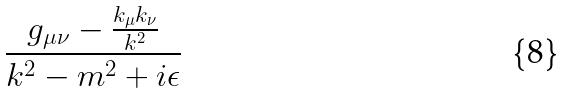Convert formula to latex. <formula><loc_0><loc_0><loc_500><loc_500>\frac { g _ { \mu \nu } - \frac { k _ { \mu } k _ { \nu } } { k ^ { 2 } } } { k ^ { 2 } - m ^ { 2 } + i \epsilon }</formula> 